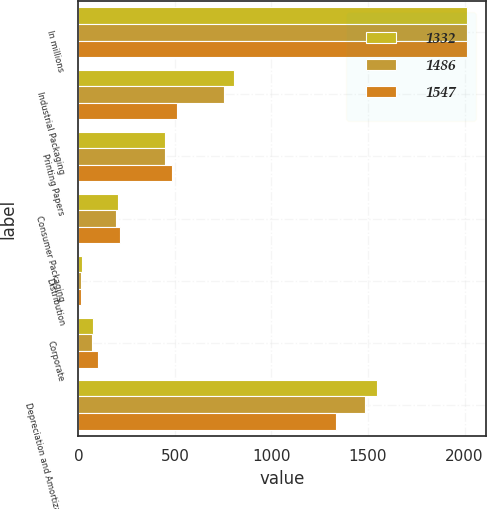Convert chart to OTSL. <chart><loc_0><loc_0><loc_500><loc_500><stacked_bar_chart><ecel><fcel>In millions<fcel>Industrial Packaging<fcel>Printing Papers<fcel>Consumer Packaging<fcel>Distribution<fcel>Corporate<fcel>Depreciation and Amortization<nl><fcel>1332<fcel>2013<fcel>805<fcel>446<fcel>206<fcel>16<fcel>74<fcel>1547<nl><fcel>1486<fcel>2012<fcel>755<fcel>450<fcel>196<fcel>13<fcel>72<fcel>1486<nl><fcel>1547<fcel>2011<fcel>513<fcel>486<fcel>217<fcel>14<fcel>102<fcel>1332<nl></chart> 